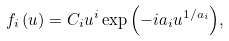Convert formula to latex. <formula><loc_0><loc_0><loc_500><loc_500>f _ { i } \left ( u \right ) = C _ { i } u ^ { i } \exp { \left ( - i a _ { i } u ^ { 1 / a _ { i } } \right ) } ,</formula> 